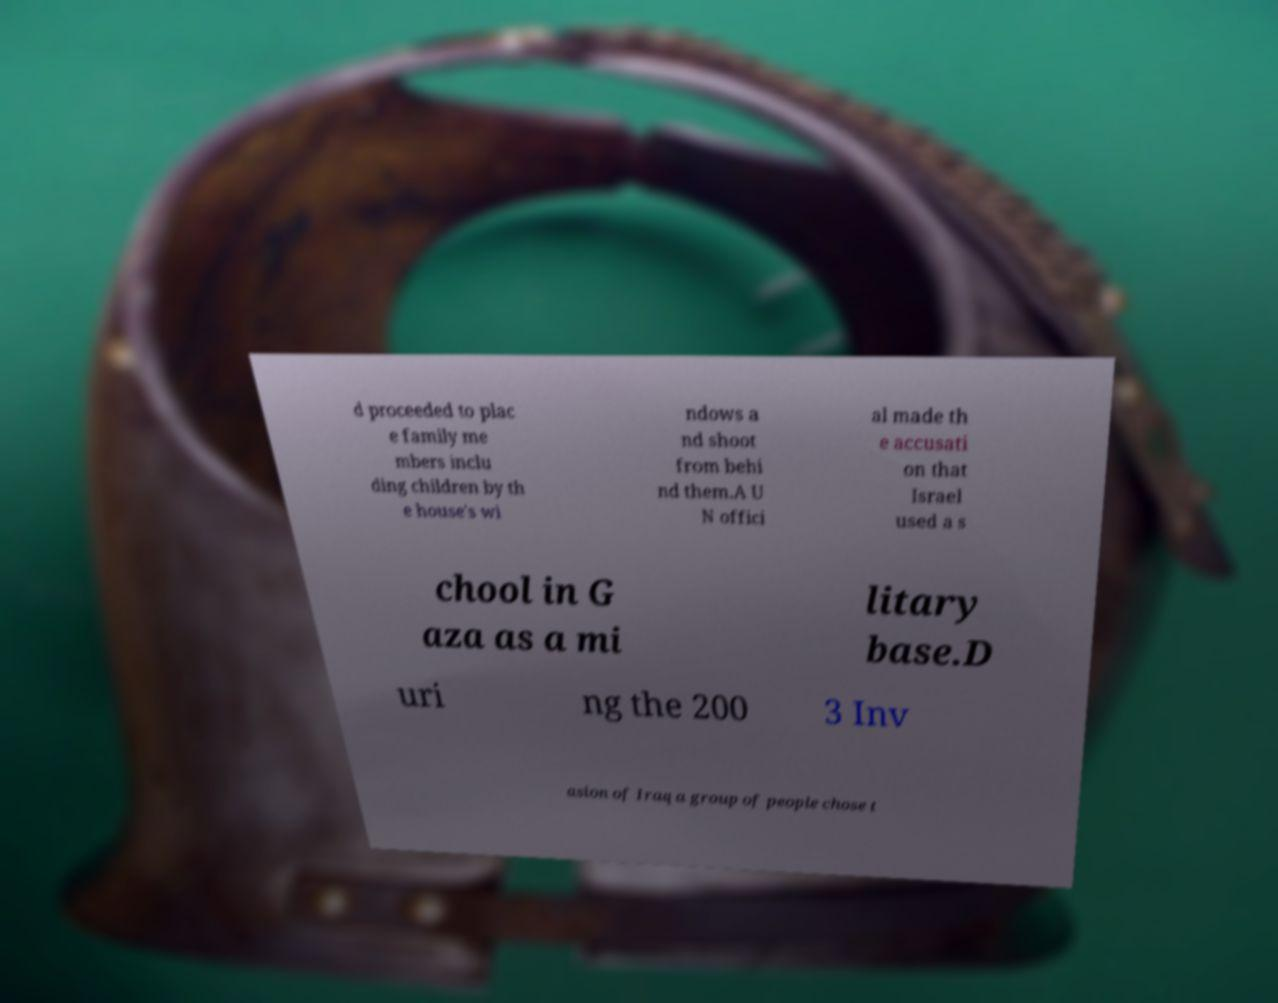For documentation purposes, I need the text within this image transcribed. Could you provide that? d proceeded to plac e family me mbers inclu ding children by th e house's wi ndows a nd shoot from behi nd them.A U N offici al made th e accusati on that Israel used a s chool in G aza as a mi litary base.D uri ng the 200 3 Inv asion of Iraq a group of people chose t 